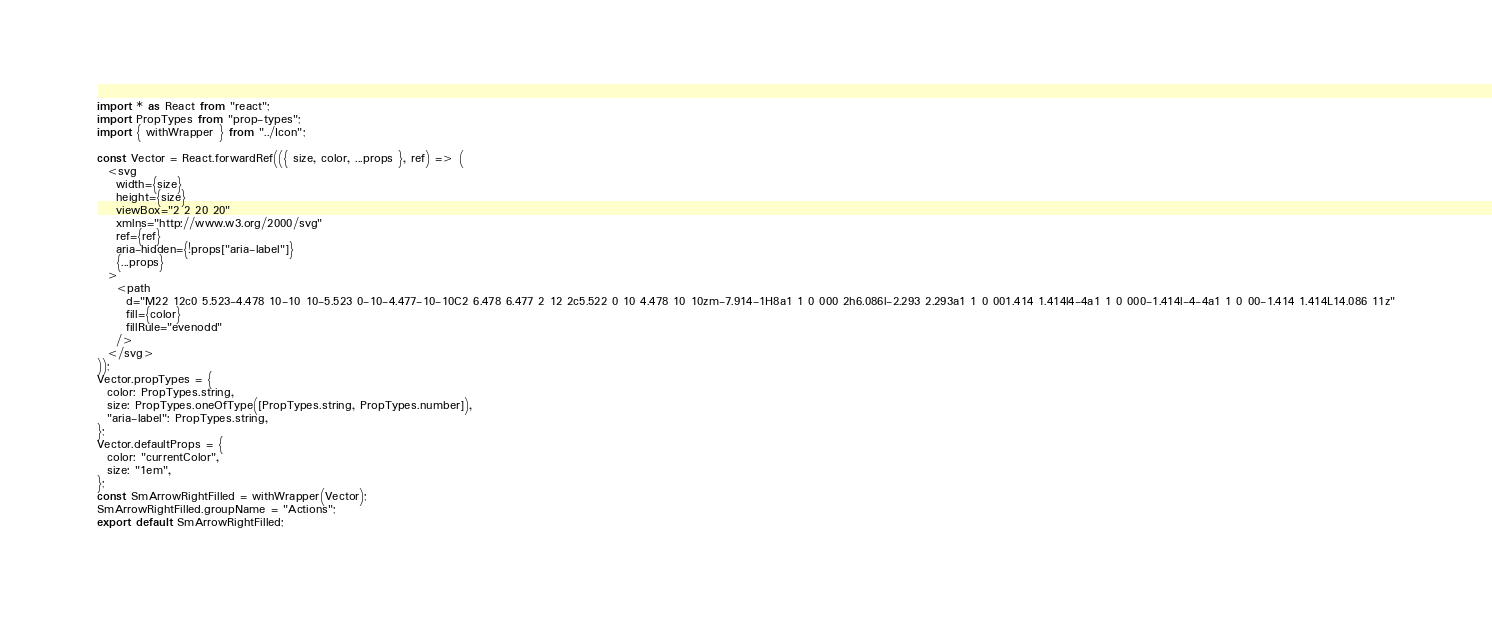Convert code to text. <code><loc_0><loc_0><loc_500><loc_500><_JavaScript_>import * as React from "react";
import PropTypes from "prop-types";
import { withWrapper } from "../Icon";

const Vector = React.forwardRef(({ size, color, ...props }, ref) => (
  <svg
    width={size}
    height={size}
    viewBox="2 2 20 20"
    xmlns="http://www.w3.org/2000/svg"
    ref={ref}
    aria-hidden={!props["aria-label"]}
    {...props}
  >
    <path
      d="M22 12c0 5.523-4.478 10-10 10-5.523 0-10-4.477-10-10C2 6.478 6.477 2 12 2c5.522 0 10 4.478 10 10zm-7.914-1H8a1 1 0 000 2h6.086l-2.293 2.293a1 1 0 001.414 1.414l4-4a1 1 0 000-1.414l-4-4a1 1 0 00-1.414 1.414L14.086 11z"
      fill={color}
      fillRule="evenodd"
    />
  </svg>
));
Vector.propTypes = {
  color: PropTypes.string,
  size: PropTypes.oneOfType([PropTypes.string, PropTypes.number]),
  "aria-label": PropTypes.string,
};
Vector.defaultProps = {
  color: "currentColor",
  size: "1em",
};
const SmArrowRightFilled = withWrapper(Vector);
SmArrowRightFilled.groupName = "Actions";
export default SmArrowRightFilled;
</code> 